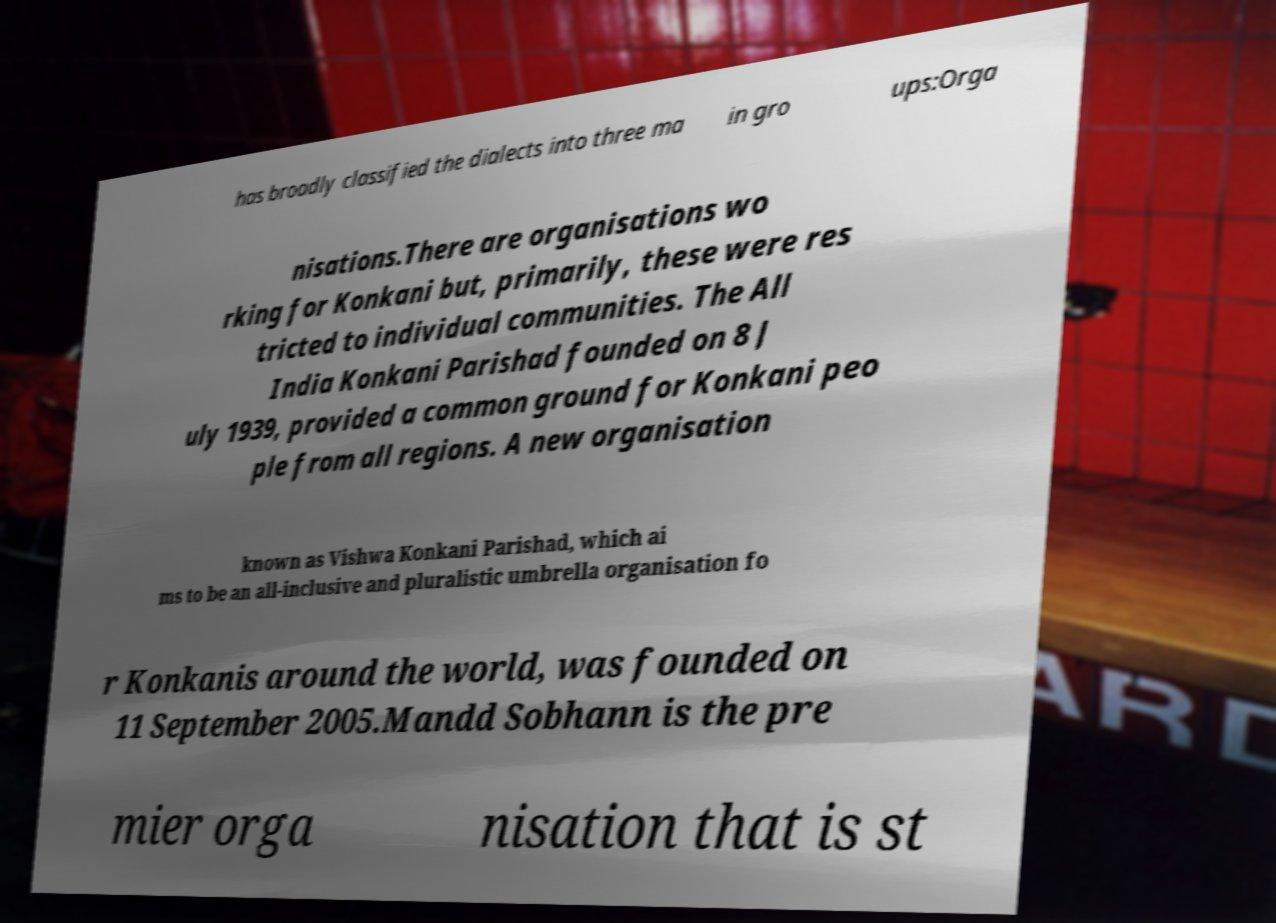Can you read and provide the text displayed in the image?This photo seems to have some interesting text. Can you extract and type it out for me? has broadly classified the dialects into three ma in gro ups:Orga nisations.There are organisations wo rking for Konkani but, primarily, these were res tricted to individual communities. The All India Konkani Parishad founded on 8 J uly 1939, provided a common ground for Konkani peo ple from all regions. A new organisation known as Vishwa Konkani Parishad, which ai ms to be an all-inclusive and pluralistic umbrella organisation fo r Konkanis around the world, was founded on 11 September 2005.Mandd Sobhann is the pre mier orga nisation that is st 